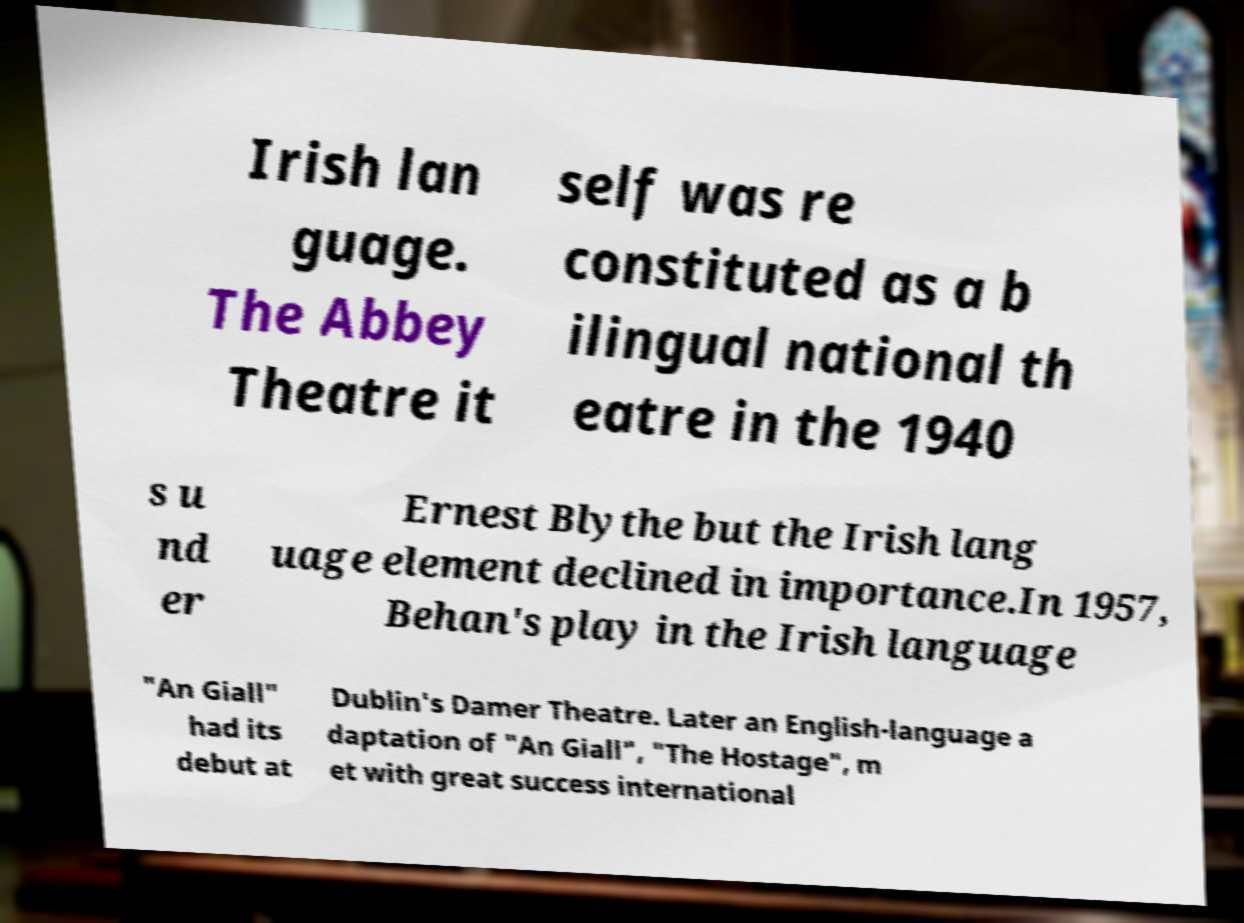Can you read and provide the text displayed in the image?This photo seems to have some interesting text. Can you extract and type it out for me? Irish lan guage. The Abbey Theatre it self was re constituted as a b ilingual national th eatre in the 1940 s u nd er Ernest Blythe but the Irish lang uage element declined in importance.In 1957, Behan's play in the Irish language "An Giall" had its debut at Dublin's Damer Theatre. Later an English-language a daptation of "An Giall", "The Hostage", m et with great success international 